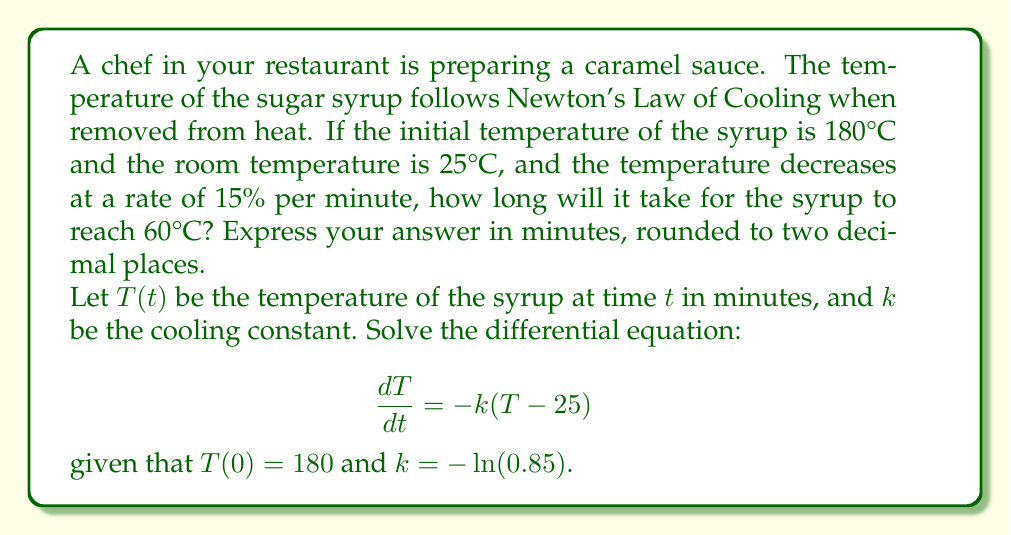Solve this math problem. To solve this problem, we'll follow these steps:

1) First, we need to solve the given differential equation:
   $$\frac{dT}{dt} = -k(T - 25)$$

2) This is a separable equation. Rearranging it:
   $$\frac{dT}{T - 25} = -k dt$$

3) Integrating both sides:
   $$\int \frac{dT}{T - 25} = -k \int dt$$
   $$\ln|T - 25| = -kt + C$$

4) Using the initial condition $T(0) = 180$:
   $$\ln(180 - 25) = C$$
   $$C = \ln(155)$$

5) Substituting back:
   $$\ln|T - 25| = -kt + \ln(155)$$

6) Solving for T:
   $$T = 25 + 155e^{-kt}$$

7) Now, we need to find $k$. We're told that the temperature decreases at a rate of 15% per minute. This means that after 1 minute, the temperature difference from room temperature is 85% of what it was initially. So:
   $$e^{-k} = 0.85$$
   $$k = -\ln(0.85) \approx 0.1625$$

8) Now we can solve for the time when $T = 60°C$:
   $$60 = 25 + 155e^{-0.1625t}$$
   $$35 = 155e^{-0.1625t}$$
   $$\frac{35}{155} = e^{-0.1625t}$$
   $$\ln(\frac{35}{155}) = -0.1625t$$
   $$t = -\frac{\ln(\frac{35}{155})}{0.1625} \approx 9.4964$$
Answer: It will take approximately 9.50 minutes for the syrup to reach 60°C. 